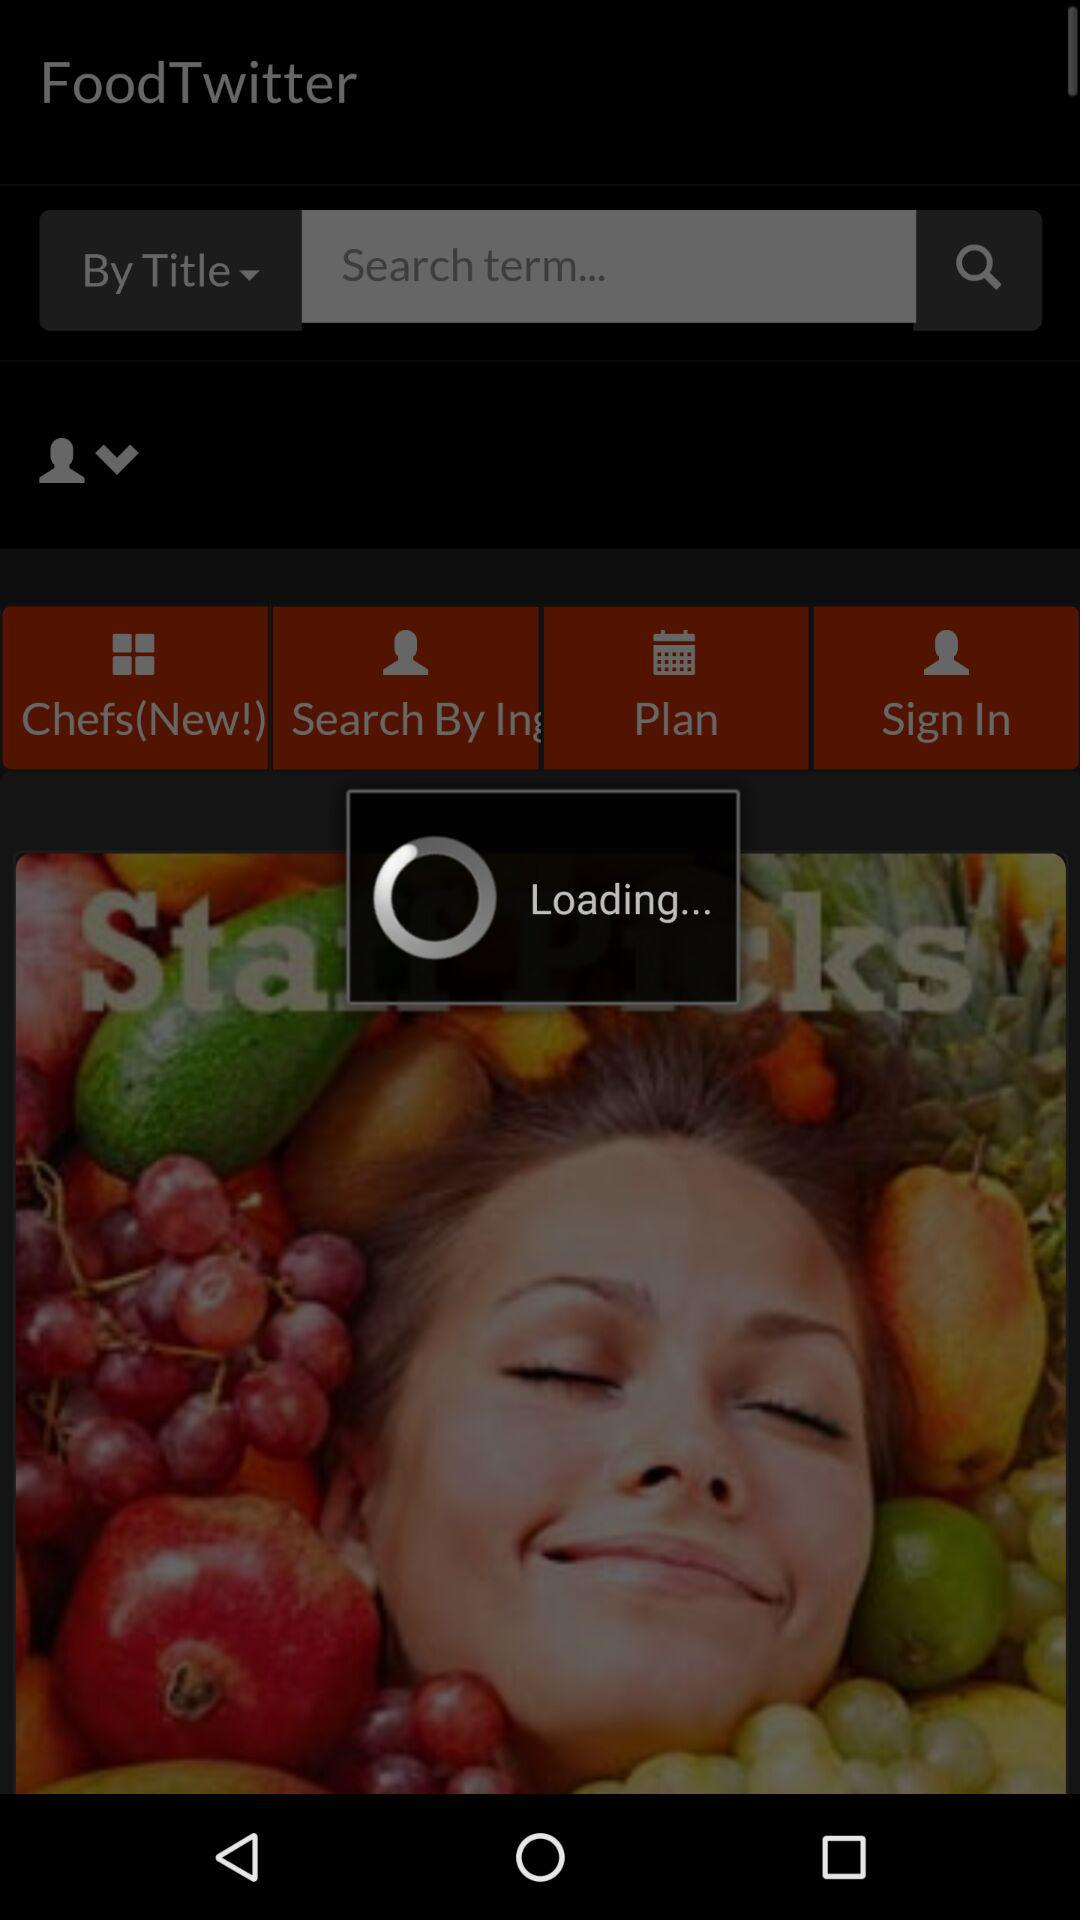What is the name of the application? The name of the application is "FoodTwitter - Chinese". 